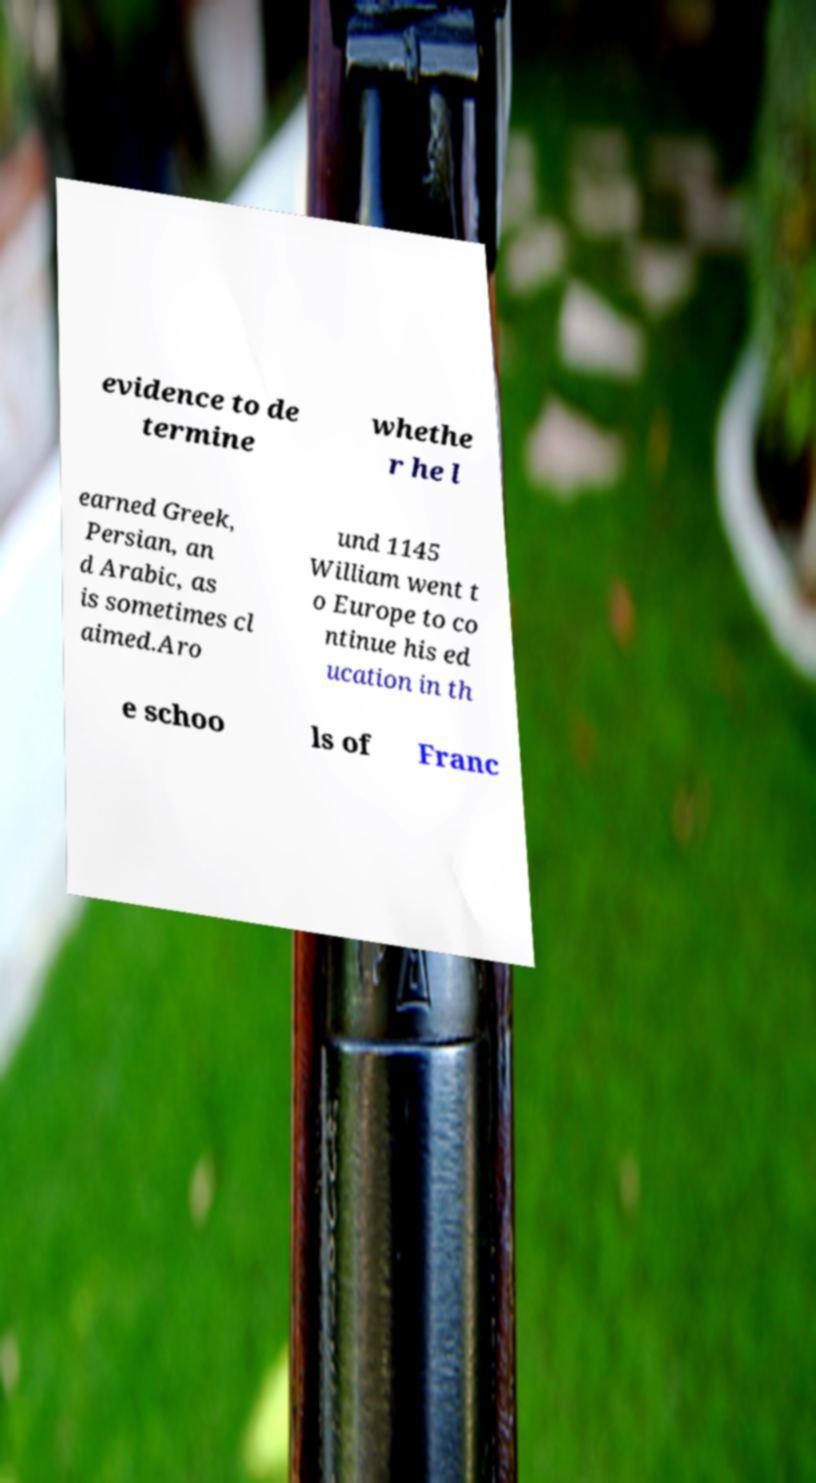Could you assist in decoding the text presented in this image and type it out clearly? evidence to de termine whethe r he l earned Greek, Persian, an d Arabic, as is sometimes cl aimed.Aro und 1145 William went t o Europe to co ntinue his ed ucation in th e schoo ls of Franc 